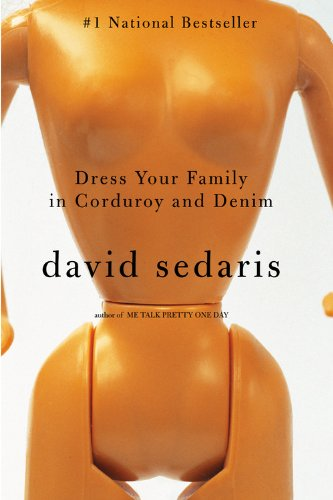What is the genre of this book? This book falls under the genre of Humor & Entertainment, containing a collection of autobiographical essays that blend sharp humor with deep insights. 